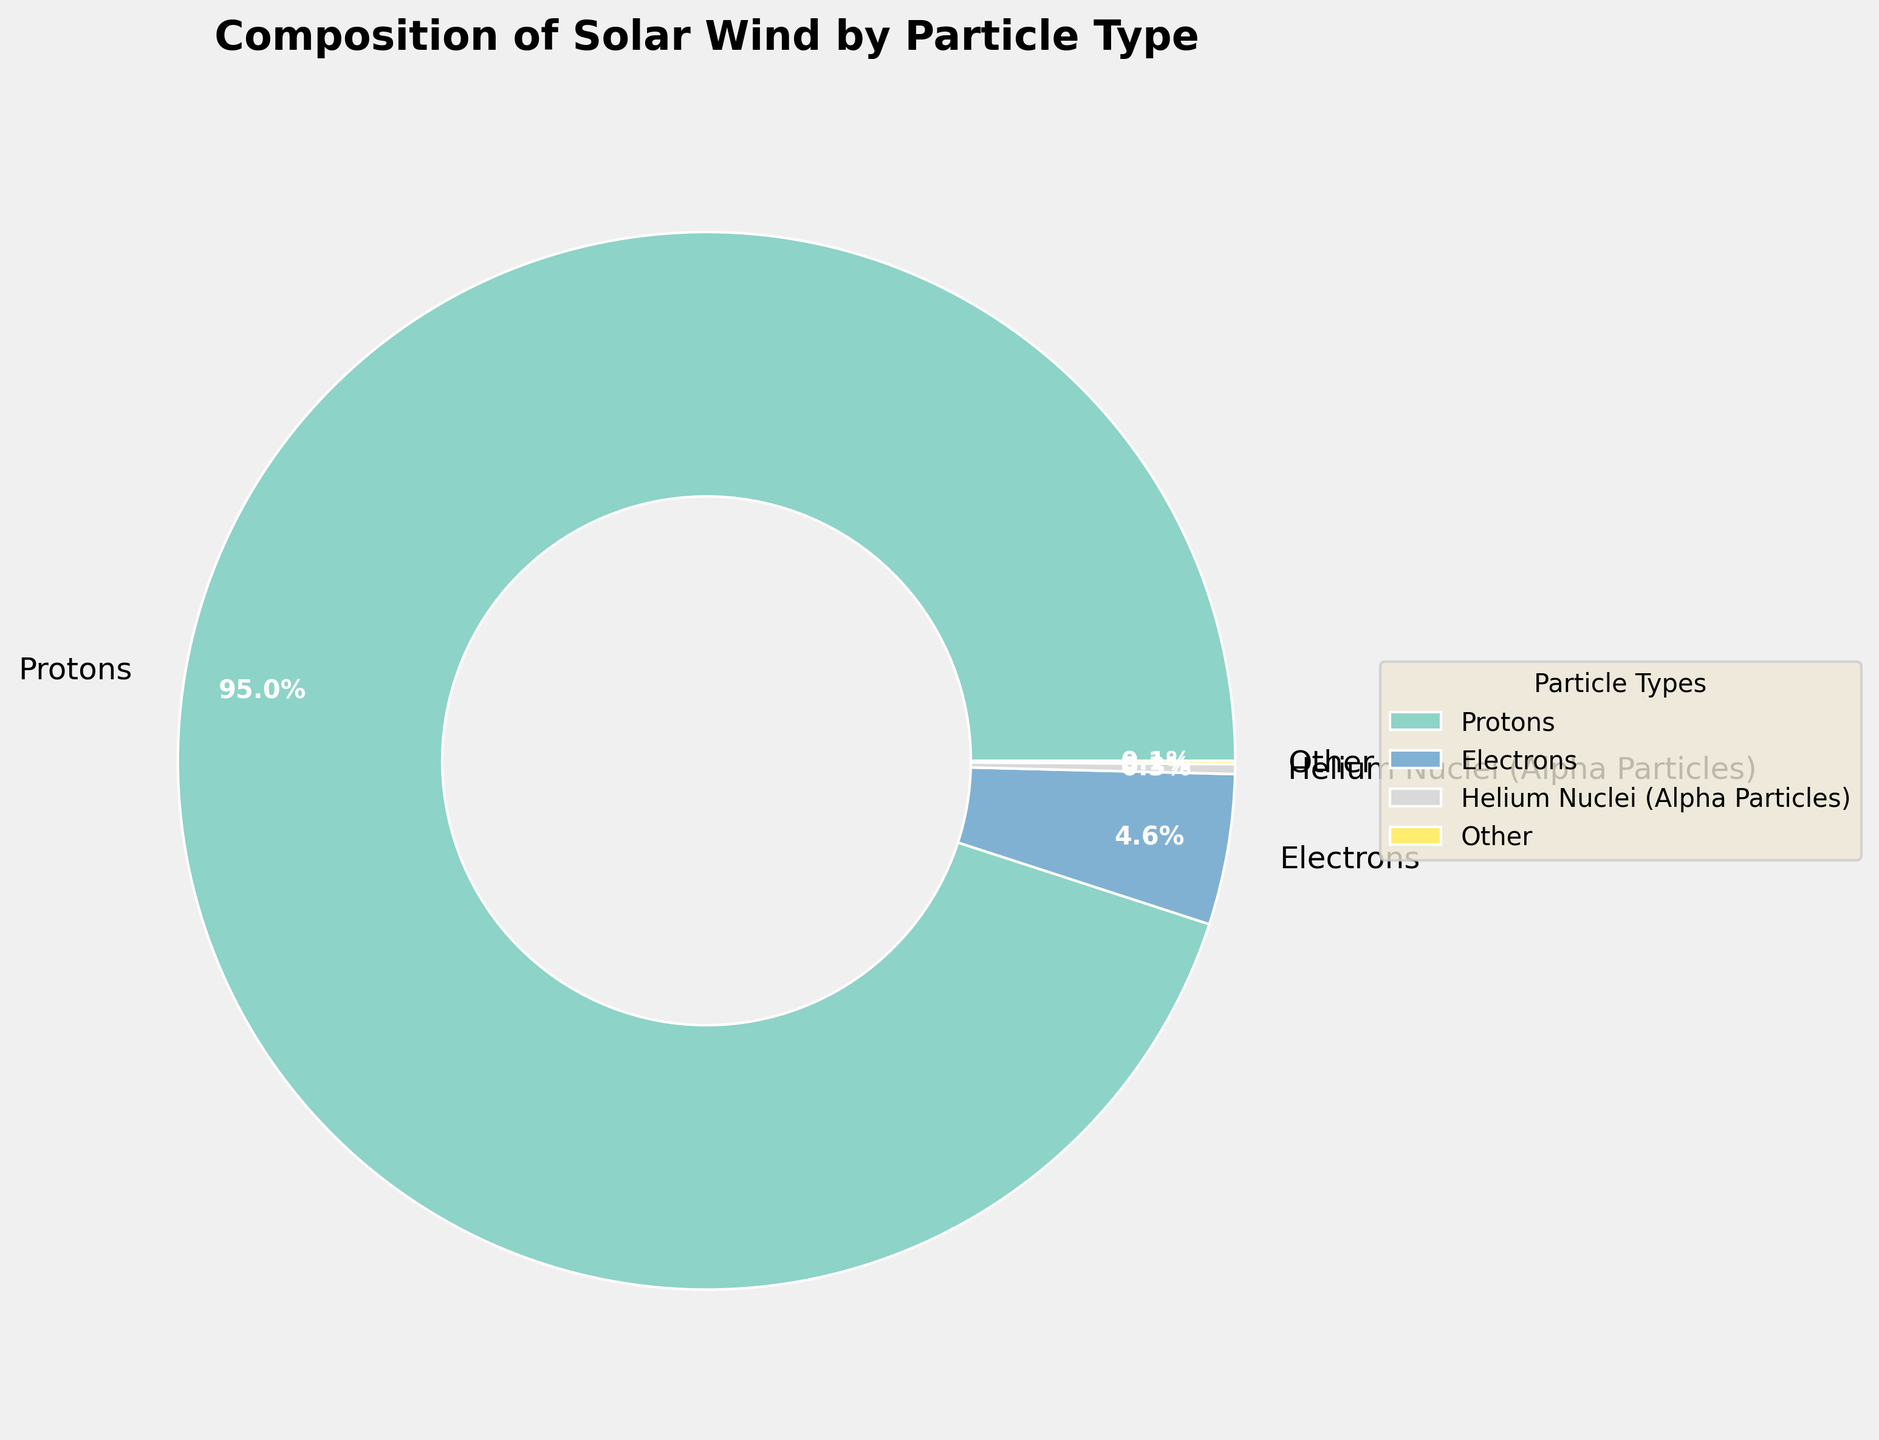What percentage of the solar wind is composed of particles other than protons and electrons? Combine the percentages of helium nuclei (0.3%) and other ions (oxygen, carbon, nitrogen, neon, silicon, magnesium ions) which adds up to 0.385% and round it due to minor numerical differences.
Answer: 0.4% Which particle type constitutes the largest part of the solar wind? The largest segment of the pie chart is labeled as "Protons," and the percentage given is 95.0%.
Answer: Protons How does the percentage of helium nuclei compare to the percentage of electrons? Helium nuclei make up 0.3% of the solar wind, while electrons make up 4.6%. Thus, electrons are much more prevalent.
Answer: Electrons are more prevalent What is the total percentage composition of ions (excluding protons and electrons) and how is this visually shown? Add up the percentages of helium nuclei (0.3%), oxygen ions (0.05%), carbon ions (0.03%), nitrogen ions (0.01%), neon ions (0.005%), silicon ions (0.003%), and magnesium ions (0.002%). This totals 0.4%. These smaller segments are grouped into an "Other" category in the pie chart for better visibility.
Answer: 0.4% What can be inferred from the predominance of a single particle type in the solar wind? Since protons make up 95% of the solar wind, it indicates that the solar wind is overwhelmingly composed of protons compared to other particle types.
Answer: The solar wind is mostly protons Can you visually identify the part of the chart labeled as "Other"? What does it signify? The "Other" section is visually represented by a small segment of the pie chart. It signifies the combined smaller contributions of all ions excluding protons, electrons, and helium nuclei.
Answer: Small segment labeled "Other" Which particle type, other than protons, has the highest percentage in the solar wind? The pie chart shows that electrons have the second highest percentage at 4.6%.
Answer: Electrons What is the relative size of the pie chart segment for "Other" compared to helium nuclei? The "Other" segment makes up around 0.4%, while helium nuclei make up 0.3%. Hence, the "Other" segment is slightly larger.
Answer: "Other" is slightly larger than helium nuclei By what factor is the percentage of protons larger than the percentage of helium nuclei? Divide the percentage of protons (95.0%) by the percentage of helium nuclei (0.3%), which results in approximately 316.67.
Answer: Approximately 317 If you combine the percentages of electrons and helium nuclei, how do they compare to protons? Adding 4.6% (electrons) and 0.3% (helium nuclei) gives 4.9%, which is significantly less than the 95.0% of protons.
Answer: Protons are still much higher 